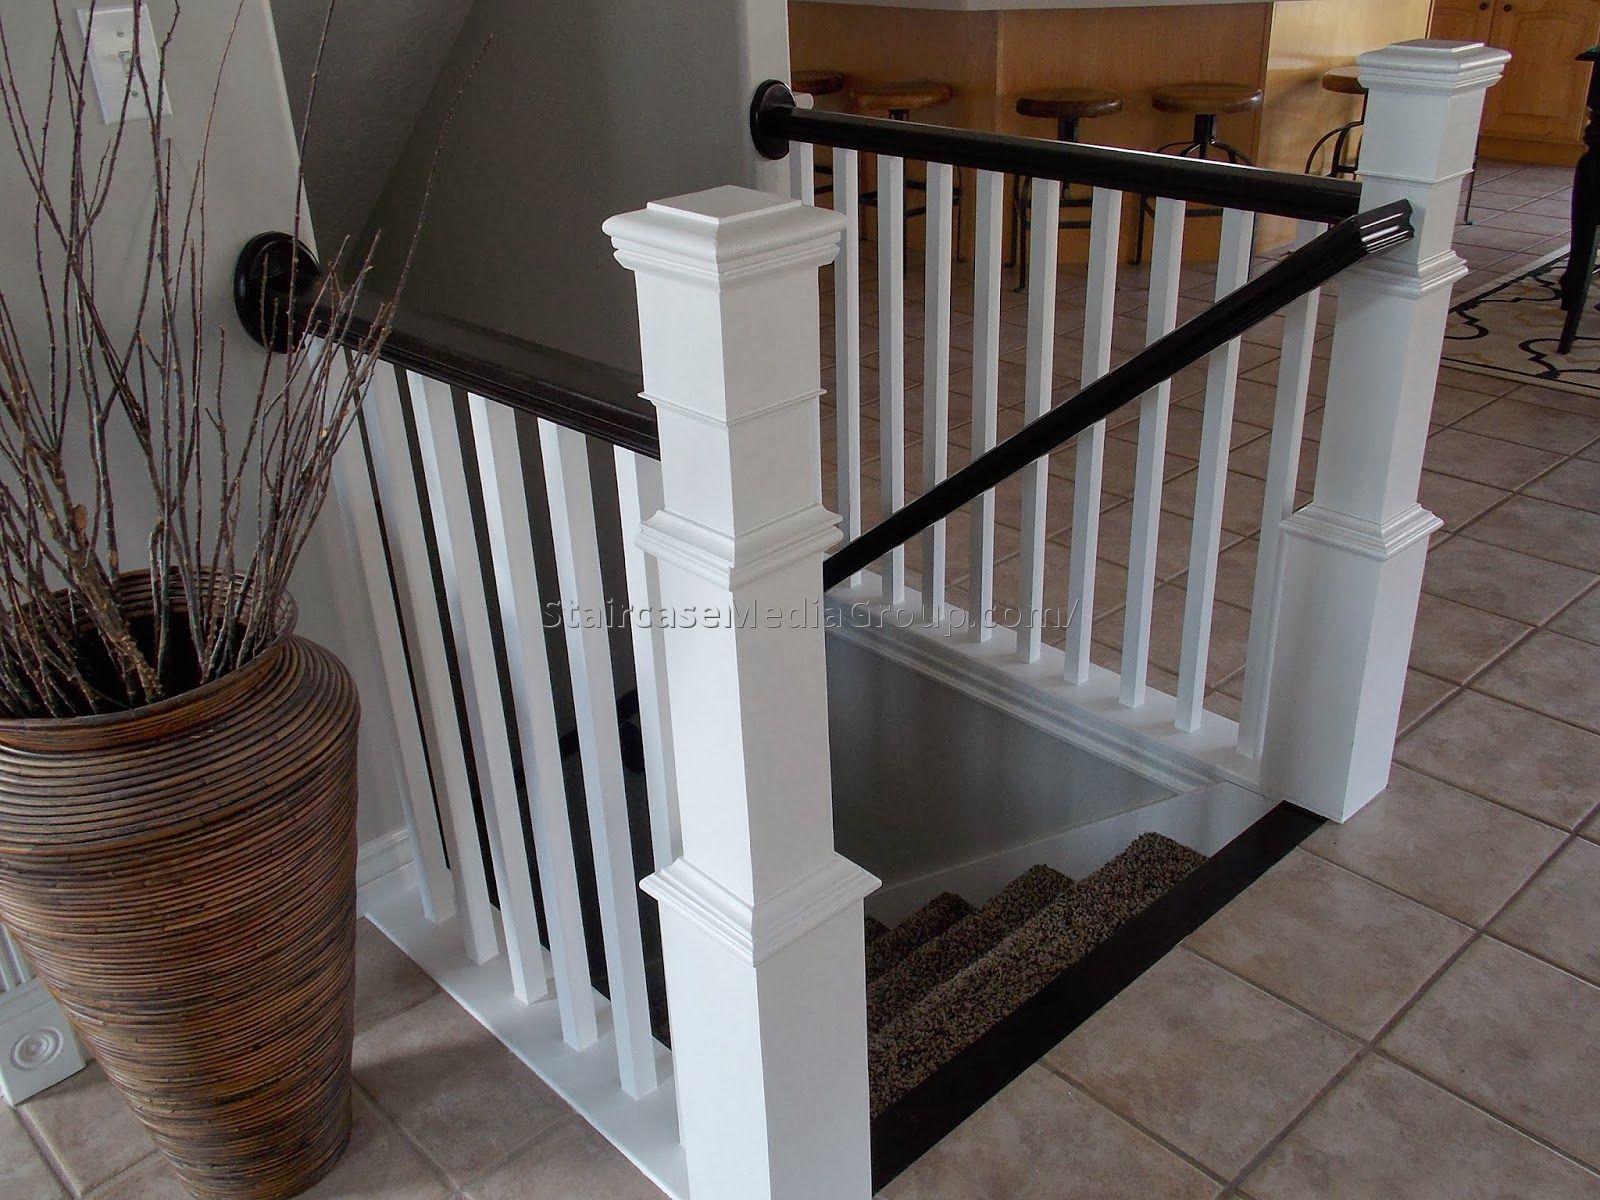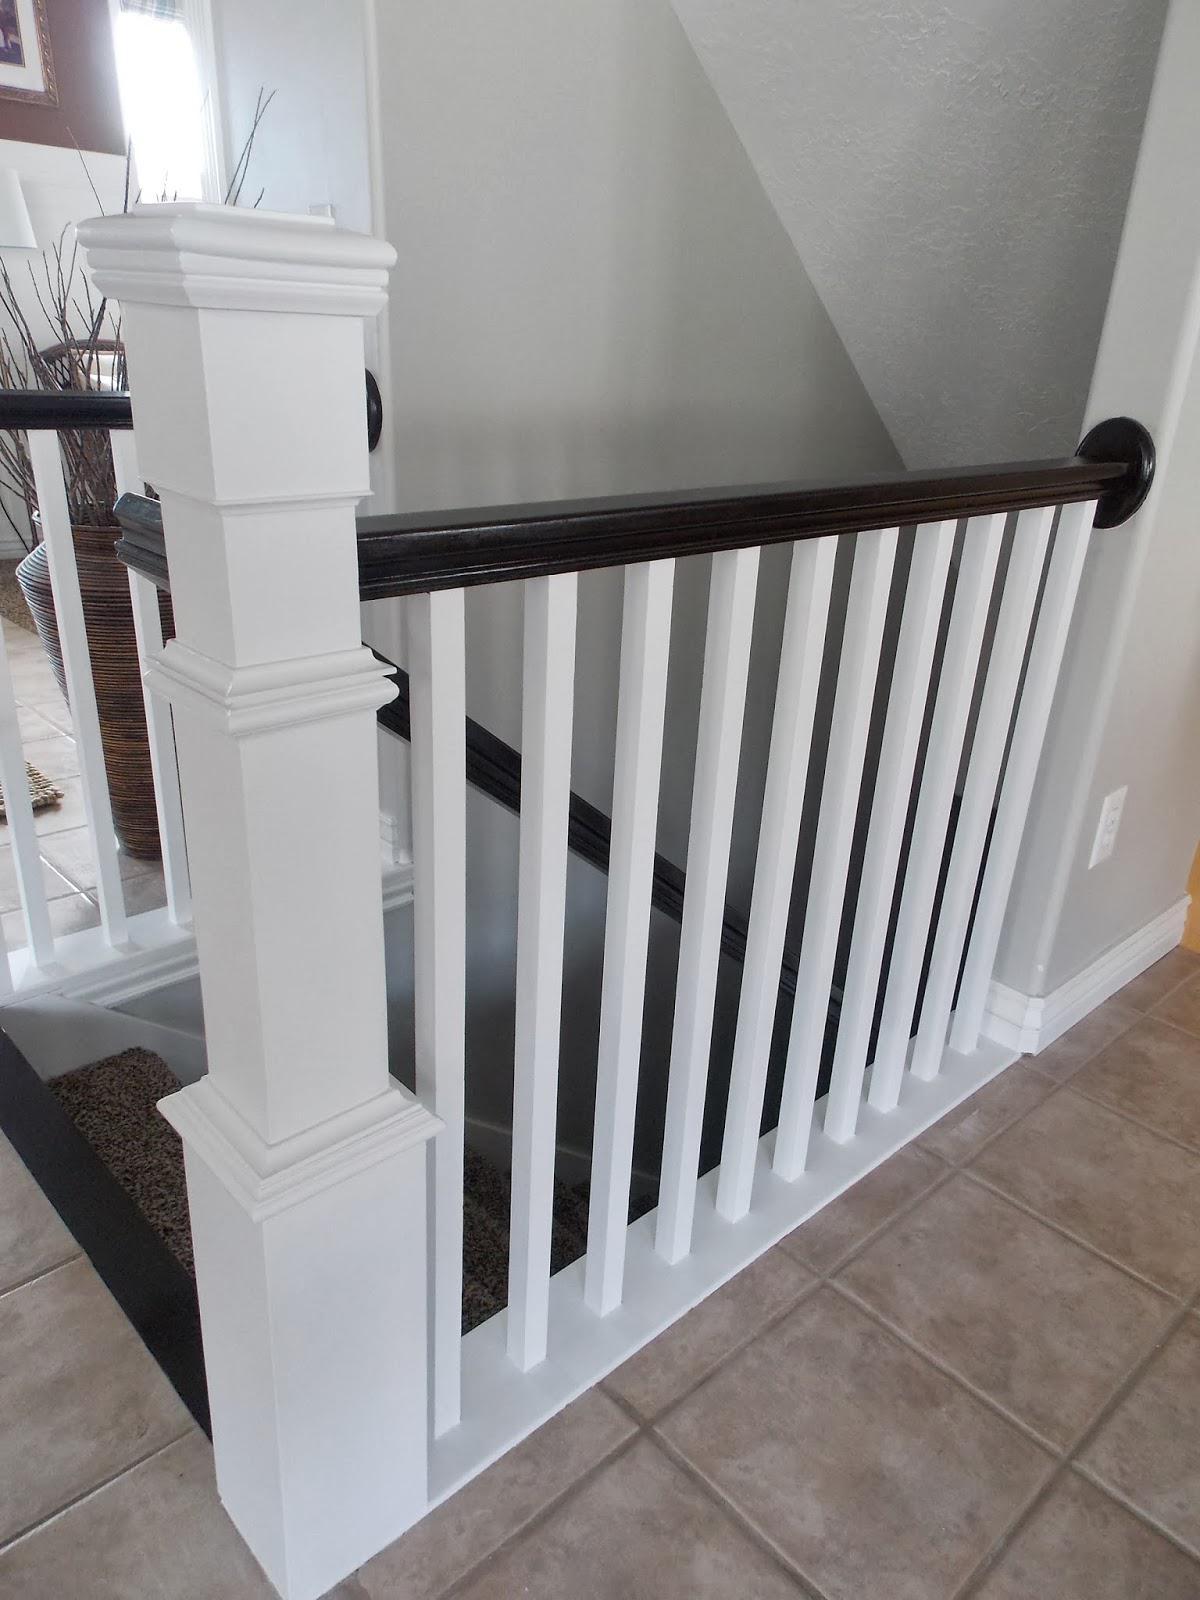The first image is the image on the left, the second image is the image on the right. Given the left and right images, does the statement "Each image shows at least one square corner post and straight white bars flanking a descending flight of stairs." hold true? Answer yes or no. Yes. The first image is the image on the left, the second image is the image on the right. For the images shown, is this caption "All of the banister posts are painted white." true? Answer yes or no. Yes. 